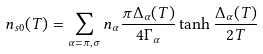Convert formula to latex. <formula><loc_0><loc_0><loc_500><loc_500>n _ { s 0 } ( T ) = \sum _ { \alpha = \pi , \sigma } n _ { \alpha } \frac { \pi \Delta _ { \alpha } ( T ) } { 4 \Gamma _ { \alpha } } \tanh \frac { \Delta _ { \alpha } ( T ) } { 2 T }</formula> 